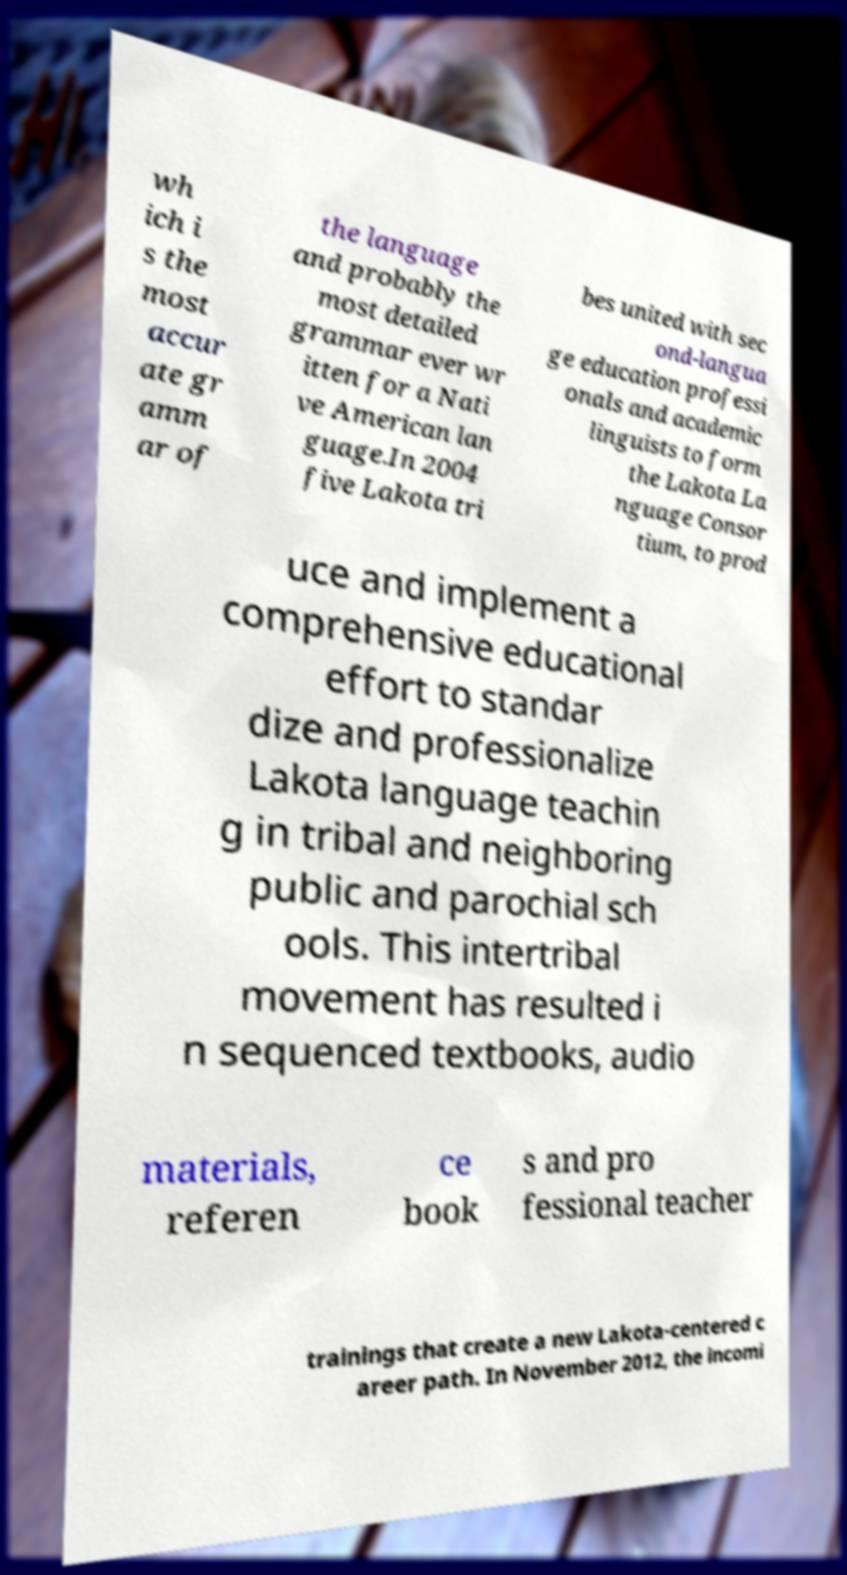Can you accurately transcribe the text from the provided image for me? wh ich i s the most accur ate gr amm ar of the language and probably the most detailed grammar ever wr itten for a Nati ve American lan guage.In 2004 five Lakota tri bes united with sec ond-langua ge education professi onals and academic linguists to form the Lakota La nguage Consor tium, to prod uce and implement a comprehensive educational effort to standar dize and professionalize Lakota language teachin g in tribal and neighboring public and parochial sch ools. This intertribal movement has resulted i n sequenced textbooks, audio materials, referen ce book s and pro fessional teacher trainings that create a new Lakota-centered c areer path. In November 2012, the incomi 